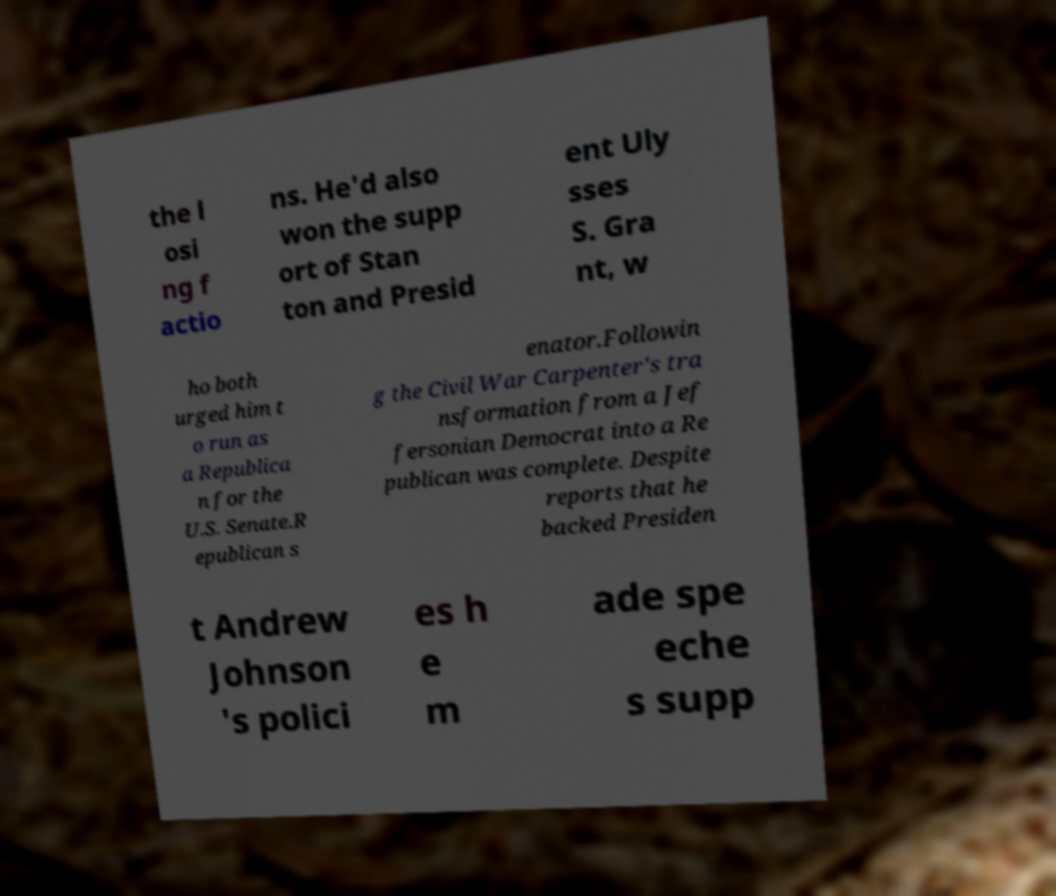Can you read and provide the text displayed in the image?This photo seems to have some interesting text. Can you extract and type it out for me? the l osi ng f actio ns. He'd also won the supp ort of Stan ton and Presid ent Uly sses S. Gra nt, w ho both urged him t o run as a Republica n for the U.S. Senate.R epublican s enator.Followin g the Civil War Carpenter's tra nsformation from a Jef fersonian Democrat into a Re publican was complete. Despite reports that he backed Presiden t Andrew Johnson 's polici es h e m ade spe eche s supp 